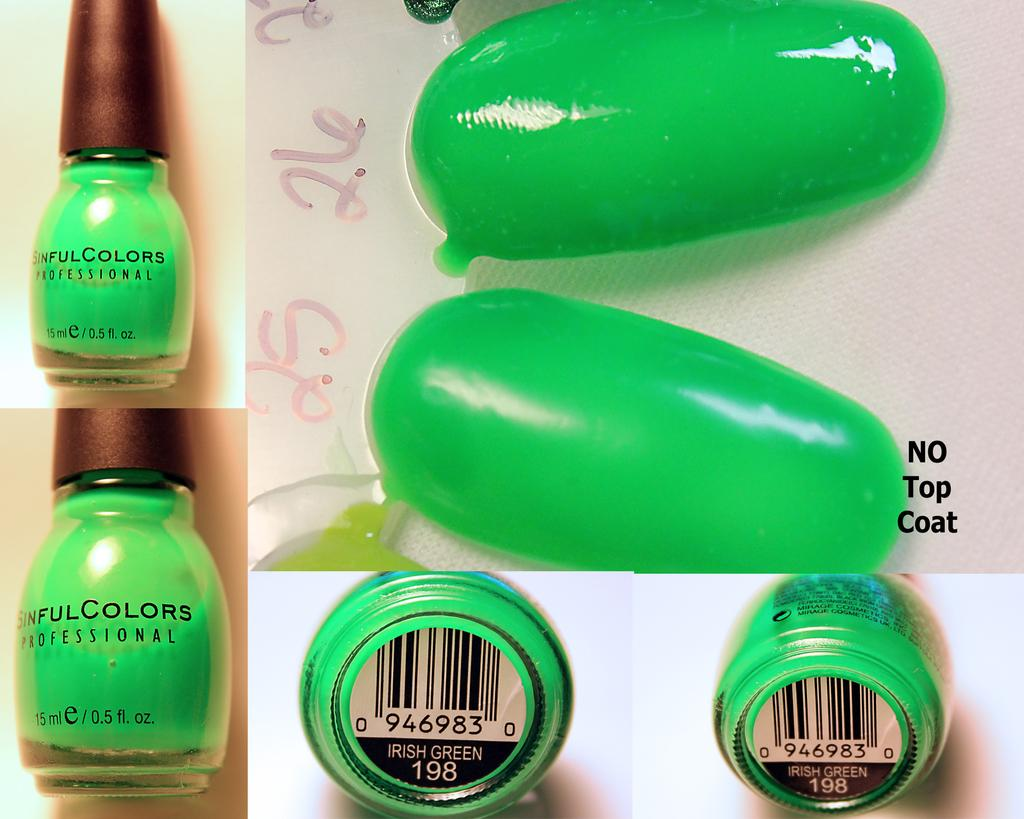<image>
Describe the image concisely. Irish green nail polish from Sinful Colors is shown on nails and in a jar. 